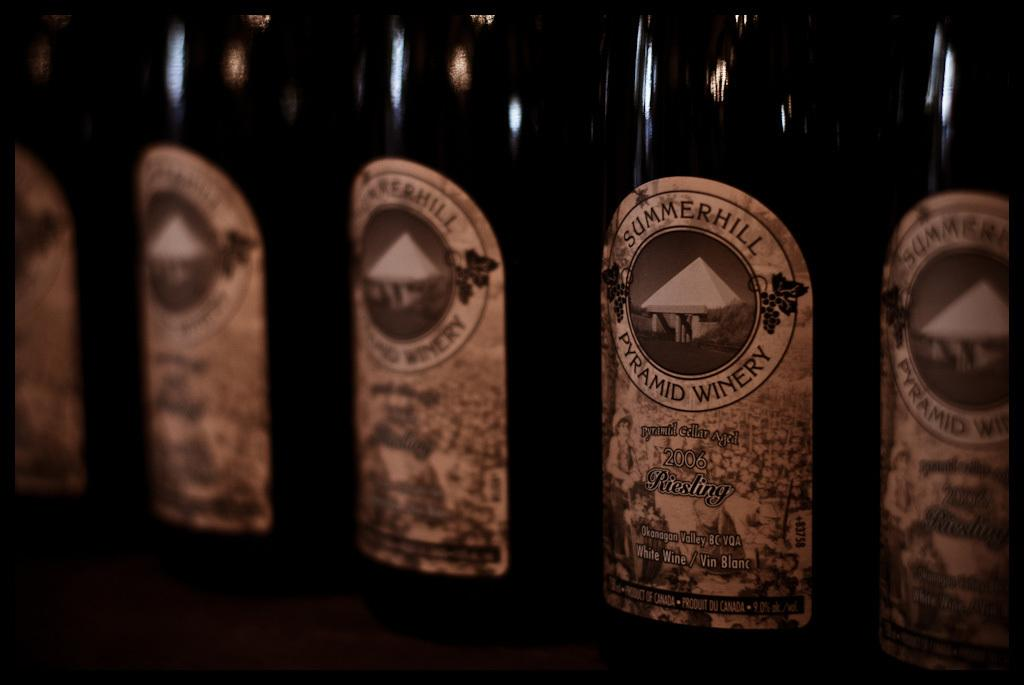What piece of furniture is present in the image? There is a table in the image. What objects are on the table? There are bottles on the table. Can you describe the lighting conditions in the image? The image appears to be slightly dark. Where is the sheep located in the image? There is no sheep present in the image. Is there a dock visible in the image? There is no dock present in the image. 